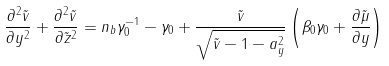Convert formula to latex. <formula><loc_0><loc_0><loc_500><loc_500>\frac { \partial ^ { 2 } { \tilde { v } } } { \partial { y ^ { 2 } } } + \frac { \partial ^ { 2 } { \tilde { v } } } { \partial { \tilde { z } ^ { 2 } } } = n _ { b } \gamma _ { 0 } ^ { - 1 } - \gamma _ { 0 } + \frac { \tilde { v } } { \sqrt { \tilde { v } - 1 - a _ { y } ^ { 2 } } } \left ( \beta _ { 0 } \gamma _ { 0 } + \frac { \partial { \tilde { \mu } } } { \partial { y } } \right )</formula> 